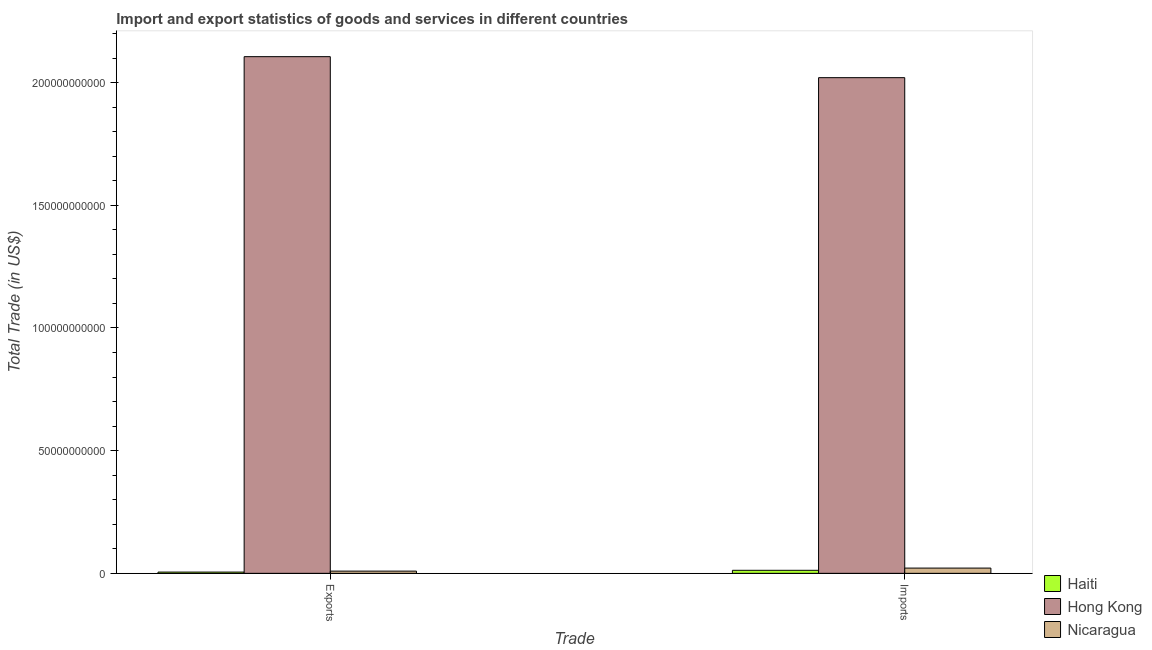How many different coloured bars are there?
Make the answer very short. 3. How many bars are there on the 2nd tick from the left?
Keep it short and to the point. 3. What is the label of the 1st group of bars from the left?
Offer a very short reply. Exports. What is the export of goods and services in Haiti?
Offer a terse response. 5.09e+08. Across all countries, what is the maximum export of goods and services?
Provide a short and direct response. 2.11e+11. Across all countries, what is the minimum export of goods and services?
Offer a very short reply. 5.09e+08. In which country was the export of goods and services maximum?
Provide a short and direct response. Hong Kong. In which country was the imports of goods and services minimum?
Keep it short and to the point. Haiti. What is the total export of goods and services in the graph?
Keep it short and to the point. 2.12e+11. What is the difference between the export of goods and services in Haiti and that in Hong Kong?
Keep it short and to the point. -2.10e+11. What is the difference between the export of goods and services in Nicaragua and the imports of goods and services in Haiti?
Ensure brevity in your answer.  -3.34e+08. What is the average imports of goods and services per country?
Provide a short and direct response. 6.85e+1. What is the difference between the export of goods and services and imports of goods and services in Nicaragua?
Provide a succinct answer. -1.24e+09. What is the ratio of the imports of goods and services in Hong Kong to that in Haiti?
Provide a succinct answer. 163.74. In how many countries, is the export of goods and services greater than the average export of goods and services taken over all countries?
Your answer should be compact. 1. What does the 1st bar from the left in Imports represents?
Your answer should be very brief. Haiti. What does the 1st bar from the right in Exports represents?
Offer a very short reply. Nicaragua. How many bars are there?
Give a very brief answer. 6. Are all the bars in the graph horizontal?
Your answer should be very brief. No. How many countries are there in the graph?
Your answer should be compact. 3. What is the difference between two consecutive major ticks on the Y-axis?
Ensure brevity in your answer.  5.00e+1. Where does the legend appear in the graph?
Provide a short and direct response. Bottom right. How many legend labels are there?
Make the answer very short. 3. How are the legend labels stacked?
Provide a short and direct response. Vertical. What is the title of the graph?
Offer a very short reply. Import and export statistics of goods and services in different countries. What is the label or title of the X-axis?
Offer a terse response. Trade. What is the label or title of the Y-axis?
Provide a short and direct response. Total Trade (in US$). What is the Total Trade (in US$) in Haiti in Exports?
Your response must be concise. 5.09e+08. What is the Total Trade (in US$) of Hong Kong in Exports?
Provide a succinct answer. 2.11e+11. What is the Total Trade (in US$) in Nicaragua in Exports?
Keep it short and to the point. 9.00e+08. What is the Total Trade (in US$) in Haiti in Imports?
Provide a short and direct response. 1.23e+09. What is the Total Trade (in US$) of Hong Kong in Imports?
Offer a terse response. 2.02e+11. What is the Total Trade (in US$) of Nicaragua in Imports?
Provide a succinct answer. 2.14e+09. Across all Trade, what is the maximum Total Trade (in US$) in Haiti?
Your response must be concise. 1.23e+09. Across all Trade, what is the maximum Total Trade (in US$) in Hong Kong?
Your answer should be very brief. 2.11e+11. Across all Trade, what is the maximum Total Trade (in US$) of Nicaragua?
Provide a short and direct response. 2.14e+09. Across all Trade, what is the minimum Total Trade (in US$) of Haiti?
Offer a very short reply. 5.09e+08. Across all Trade, what is the minimum Total Trade (in US$) in Hong Kong?
Your answer should be compact. 2.02e+11. Across all Trade, what is the minimum Total Trade (in US$) in Nicaragua?
Ensure brevity in your answer.  9.00e+08. What is the total Total Trade (in US$) in Haiti in the graph?
Provide a short and direct response. 1.74e+09. What is the total Total Trade (in US$) of Hong Kong in the graph?
Your response must be concise. 4.13e+11. What is the total Total Trade (in US$) in Nicaragua in the graph?
Keep it short and to the point. 3.04e+09. What is the difference between the Total Trade (in US$) in Haiti in Exports and that in Imports?
Provide a succinct answer. -7.25e+08. What is the difference between the Total Trade (in US$) of Hong Kong in Exports and that in Imports?
Provide a succinct answer. 8.56e+09. What is the difference between the Total Trade (in US$) of Nicaragua in Exports and that in Imports?
Offer a terse response. -1.24e+09. What is the difference between the Total Trade (in US$) in Haiti in Exports and the Total Trade (in US$) in Hong Kong in Imports?
Provide a succinct answer. -2.01e+11. What is the difference between the Total Trade (in US$) in Haiti in Exports and the Total Trade (in US$) in Nicaragua in Imports?
Your answer should be very brief. -1.63e+09. What is the difference between the Total Trade (in US$) in Hong Kong in Exports and the Total Trade (in US$) in Nicaragua in Imports?
Offer a very short reply. 2.08e+11. What is the average Total Trade (in US$) in Haiti per Trade?
Give a very brief answer. 8.71e+08. What is the average Total Trade (in US$) in Hong Kong per Trade?
Your answer should be compact. 2.06e+11. What is the average Total Trade (in US$) in Nicaragua per Trade?
Make the answer very short. 1.52e+09. What is the difference between the Total Trade (in US$) of Haiti and Total Trade (in US$) of Hong Kong in Exports?
Keep it short and to the point. -2.10e+11. What is the difference between the Total Trade (in US$) of Haiti and Total Trade (in US$) of Nicaragua in Exports?
Your answer should be compact. -3.91e+08. What is the difference between the Total Trade (in US$) in Hong Kong and Total Trade (in US$) in Nicaragua in Exports?
Your response must be concise. 2.10e+11. What is the difference between the Total Trade (in US$) of Haiti and Total Trade (in US$) of Hong Kong in Imports?
Ensure brevity in your answer.  -2.01e+11. What is the difference between the Total Trade (in US$) of Haiti and Total Trade (in US$) of Nicaragua in Imports?
Provide a succinct answer. -9.03e+08. What is the difference between the Total Trade (in US$) in Hong Kong and Total Trade (in US$) in Nicaragua in Imports?
Offer a terse response. 2.00e+11. What is the ratio of the Total Trade (in US$) of Haiti in Exports to that in Imports?
Make the answer very short. 0.41. What is the ratio of the Total Trade (in US$) of Hong Kong in Exports to that in Imports?
Provide a succinct answer. 1.04. What is the ratio of the Total Trade (in US$) in Nicaragua in Exports to that in Imports?
Offer a very short reply. 0.42. What is the difference between the highest and the second highest Total Trade (in US$) in Haiti?
Your answer should be very brief. 7.25e+08. What is the difference between the highest and the second highest Total Trade (in US$) of Hong Kong?
Provide a short and direct response. 8.56e+09. What is the difference between the highest and the second highest Total Trade (in US$) of Nicaragua?
Keep it short and to the point. 1.24e+09. What is the difference between the highest and the lowest Total Trade (in US$) in Haiti?
Provide a short and direct response. 7.25e+08. What is the difference between the highest and the lowest Total Trade (in US$) in Hong Kong?
Ensure brevity in your answer.  8.56e+09. What is the difference between the highest and the lowest Total Trade (in US$) in Nicaragua?
Make the answer very short. 1.24e+09. 